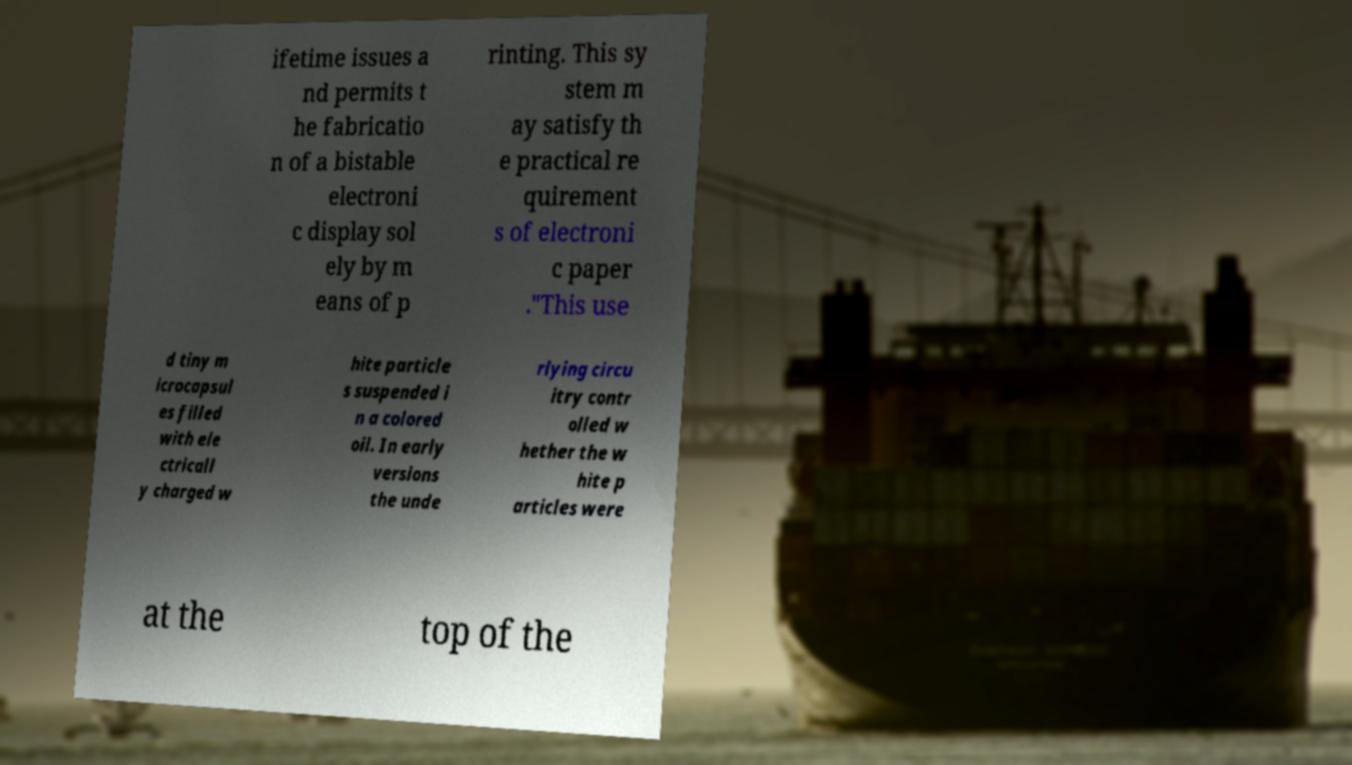Please read and relay the text visible in this image. What does it say? ifetime issues a nd permits t he fabricatio n of a bistable electroni c display sol ely by m eans of p rinting. This sy stem m ay satisfy th e practical re quirement s of electroni c paper ."This use d tiny m icrocapsul es filled with ele ctricall y charged w hite particle s suspended i n a colored oil. In early versions the unde rlying circu itry contr olled w hether the w hite p articles were at the top of the 